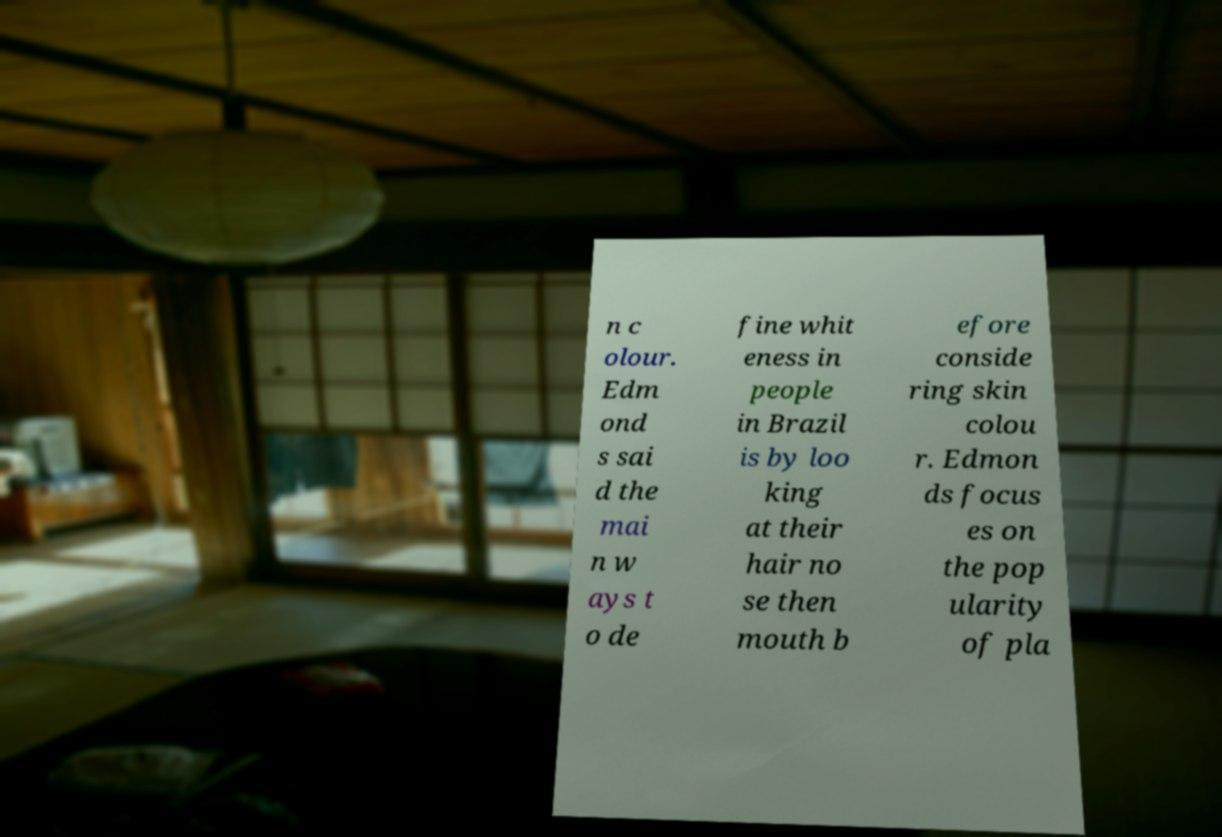I need the written content from this picture converted into text. Can you do that? n c olour. Edm ond s sai d the mai n w ays t o de fine whit eness in people in Brazil is by loo king at their hair no se then mouth b efore conside ring skin colou r. Edmon ds focus es on the pop ularity of pla 